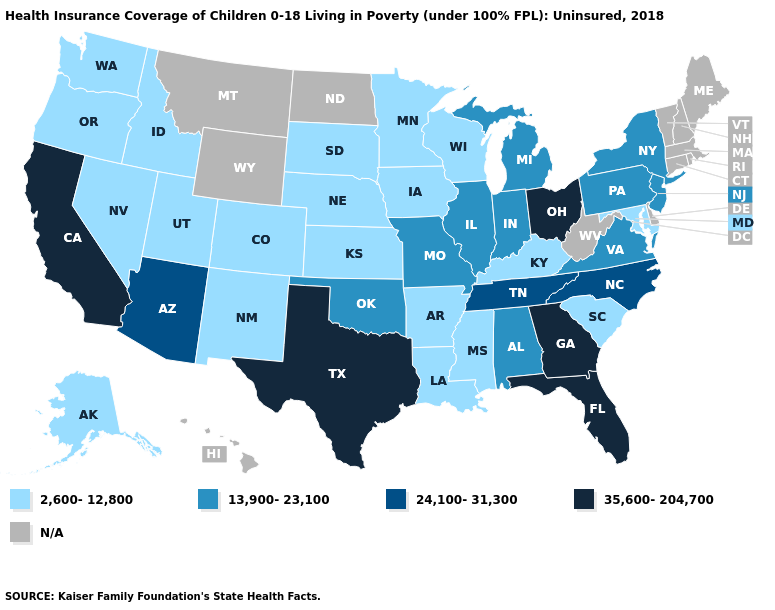Name the states that have a value in the range 35,600-204,700?
Keep it brief. California, Florida, Georgia, Ohio, Texas. Among the states that border Wisconsin , which have the lowest value?
Write a very short answer. Iowa, Minnesota. Which states have the highest value in the USA?
Give a very brief answer. California, Florida, Georgia, Ohio, Texas. What is the lowest value in states that border New Jersey?
Give a very brief answer. 13,900-23,100. What is the lowest value in the South?
Keep it brief. 2,600-12,800. Name the states that have a value in the range 13,900-23,100?
Concise answer only. Alabama, Illinois, Indiana, Michigan, Missouri, New Jersey, New York, Oklahoma, Pennsylvania, Virginia. Name the states that have a value in the range 24,100-31,300?
Concise answer only. Arizona, North Carolina, Tennessee. Name the states that have a value in the range 35,600-204,700?
Answer briefly. California, Florida, Georgia, Ohio, Texas. What is the highest value in states that border Washington?
Keep it brief. 2,600-12,800. Does the first symbol in the legend represent the smallest category?
Quick response, please. Yes. What is the value of Wisconsin?
Give a very brief answer. 2,600-12,800. What is the lowest value in the USA?
Answer briefly. 2,600-12,800. Among the states that border North Dakota , which have the lowest value?
Be succinct. Minnesota, South Dakota. Does the first symbol in the legend represent the smallest category?
Give a very brief answer. Yes. 